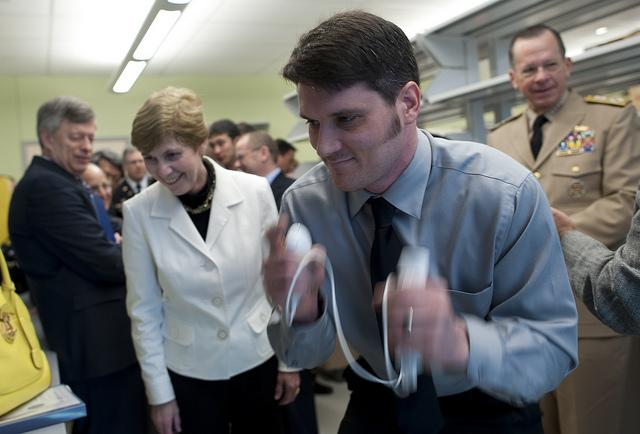What is the hair on the side of the man's cheek called?

Choices:
A) sideburn
B) mustache
C) soul patch
D) goatee sideburn 